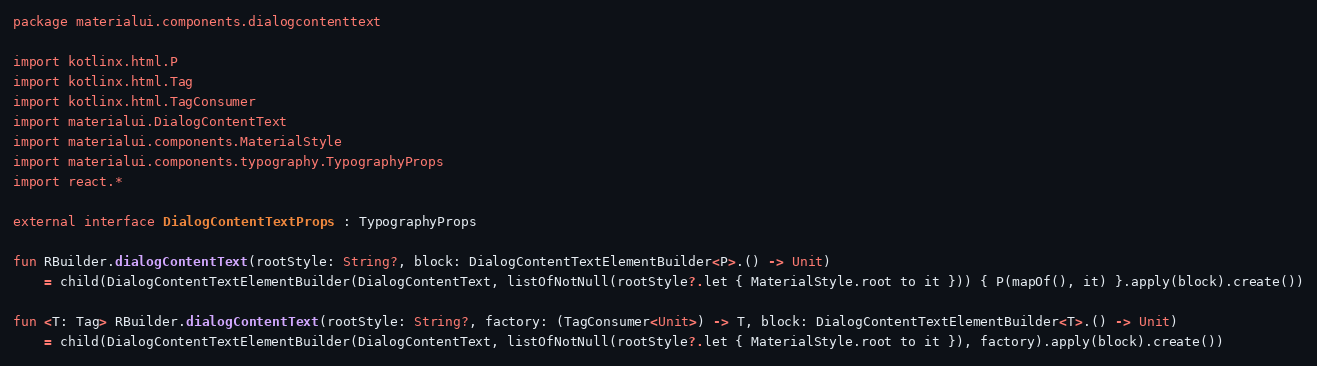Convert code to text. <code><loc_0><loc_0><loc_500><loc_500><_Kotlin_>package materialui.components.dialogcontenttext

import kotlinx.html.P
import kotlinx.html.Tag
import kotlinx.html.TagConsumer
import materialui.DialogContentText
import materialui.components.MaterialStyle
import materialui.components.typography.TypographyProps
import react.*

external interface DialogContentTextProps : TypographyProps

fun RBuilder.dialogContentText(rootStyle: String?, block: DialogContentTextElementBuilder<P>.() -> Unit)
    = child(DialogContentTextElementBuilder(DialogContentText, listOfNotNull(rootStyle?.let { MaterialStyle.root to it })) { P(mapOf(), it) }.apply(block).create())

fun <T: Tag> RBuilder.dialogContentText(rootStyle: String?, factory: (TagConsumer<Unit>) -> T, block: DialogContentTextElementBuilder<T>.() -> Unit)
    = child(DialogContentTextElementBuilder(DialogContentText, listOfNotNull(rootStyle?.let { MaterialStyle.root to it }), factory).apply(block).create())
</code> 